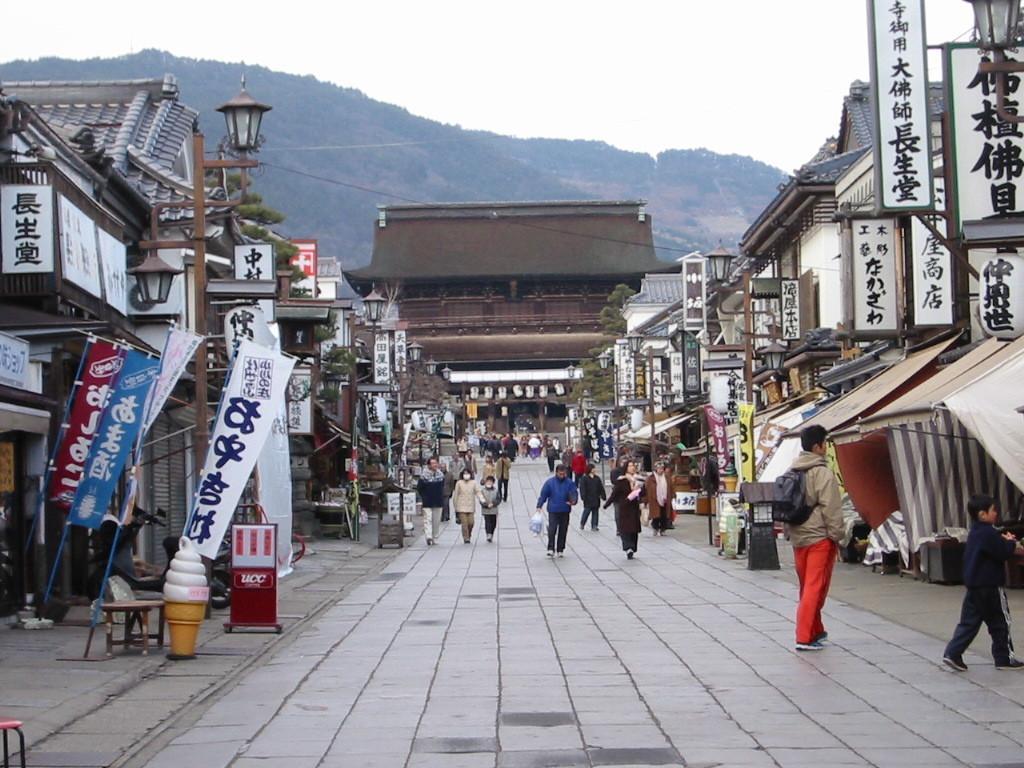Describe this image in one or two sentences. In this image we can see buildings, poles, boards, banners, table, chairs, tents, trees, and people. In the background we can see mountain and sky. 